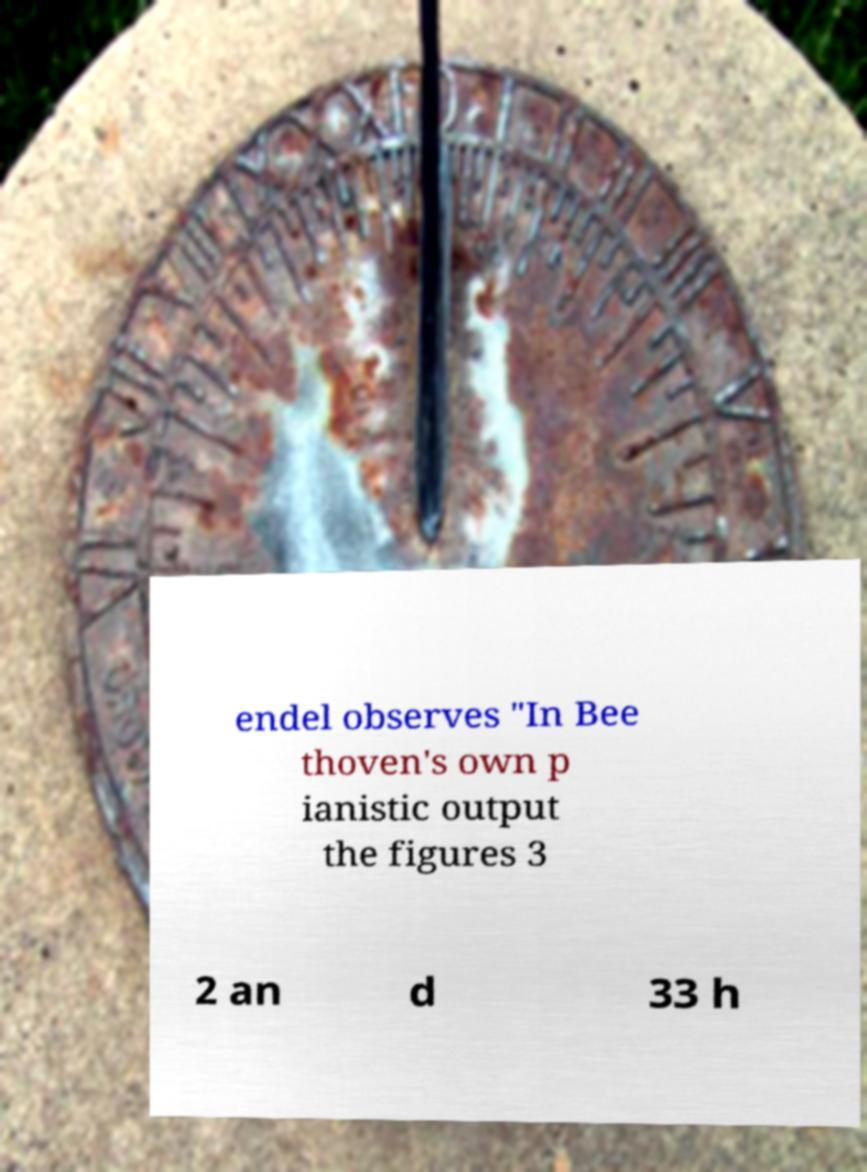Could you assist in decoding the text presented in this image and type it out clearly? endel observes "In Bee thoven's own p ianistic output the figures 3 2 an d 33 h 